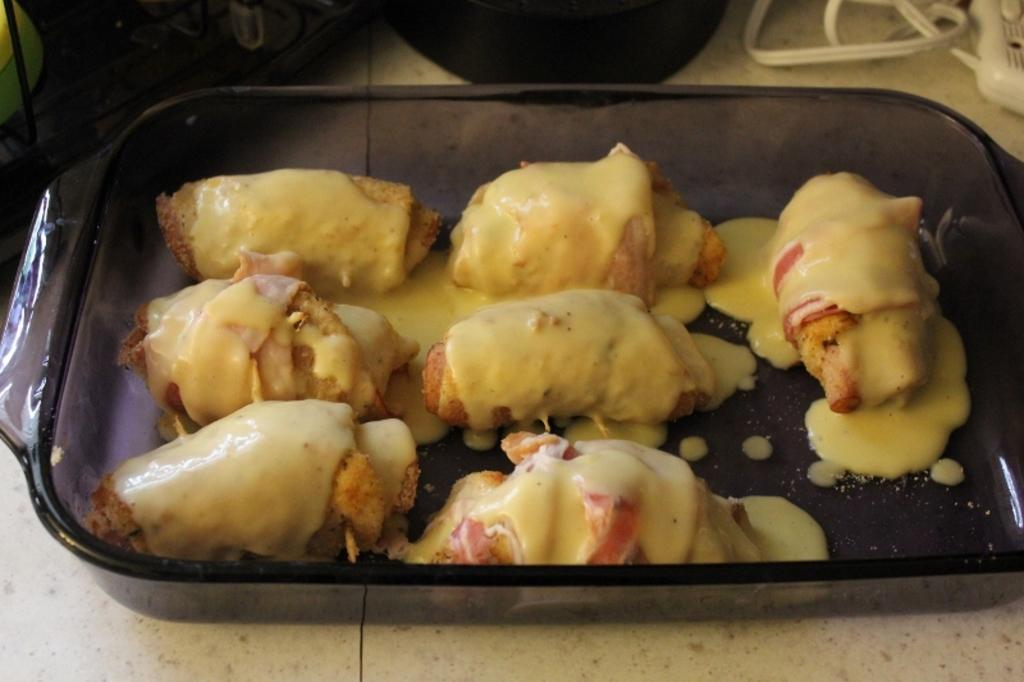What object is the main focus of the image? There is a serving tray in the image. What is on top of the food on the tray? The food on the tray has sauce on top. Can you tell me how many kitties are sitting on the serving tray in the image? There are no kitties present in the image; it only features a serving tray with food and sauce. 